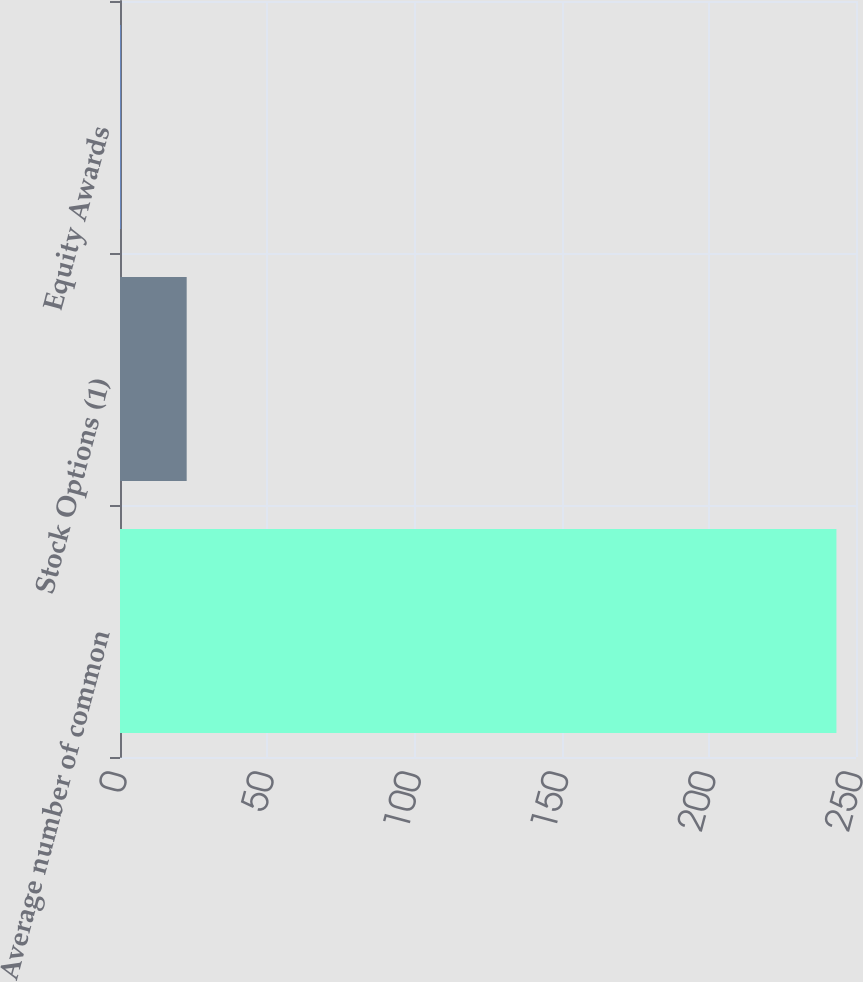<chart> <loc_0><loc_0><loc_500><loc_500><bar_chart><fcel>Average number of common<fcel>Stock Options (1)<fcel>Equity Awards<nl><fcel>243.35<fcel>22.65<fcel>0.2<nl></chart> 